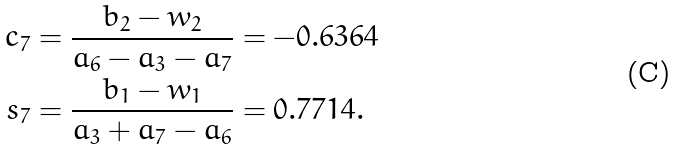<formula> <loc_0><loc_0><loc_500><loc_500>c _ { 7 } & = \frac { b _ { 2 } - w _ { 2 } } { a _ { 6 } - a _ { 3 } - a _ { 7 } } = - 0 . 6 3 6 4 \\ s _ { 7 } & = \frac { b _ { 1 } - w _ { 1 } } { a _ { 3 } + a _ { 7 } - a _ { 6 } } = 0 . 7 7 1 4 .</formula> 